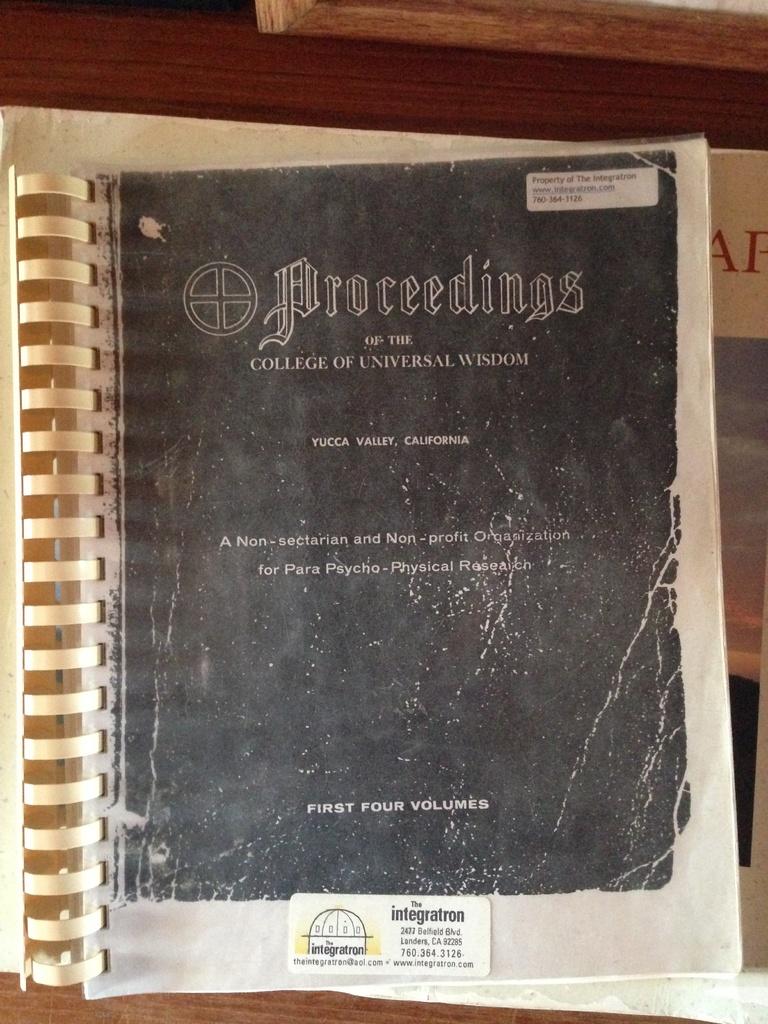What college is this book?
Offer a terse response. Universal wisdom. 